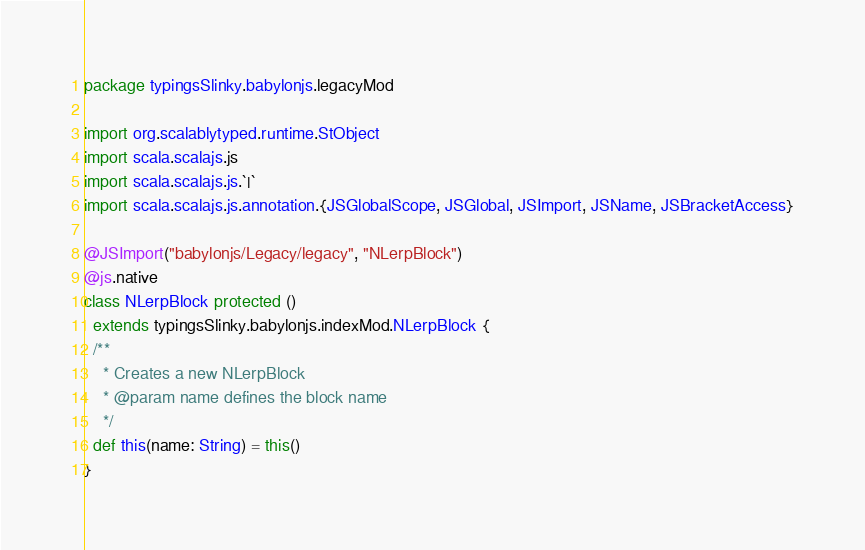<code> <loc_0><loc_0><loc_500><loc_500><_Scala_>package typingsSlinky.babylonjs.legacyMod

import org.scalablytyped.runtime.StObject
import scala.scalajs.js
import scala.scalajs.js.`|`
import scala.scalajs.js.annotation.{JSGlobalScope, JSGlobal, JSImport, JSName, JSBracketAccess}

@JSImport("babylonjs/Legacy/legacy", "NLerpBlock")
@js.native
class NLerpBlock protected ()
  extends typingsSlinky.babylonjs.indexMod.NLerpBlock {
  /**
    * Creates a new NLerpBlock
    * @param name defines the block name
    */
  def this(name: String) = this()
}
</code> 